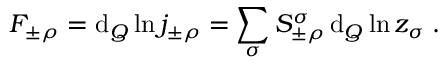<formula> <loc_0><loc_0><loc_500><loc_500>F _ { \pm \rho } = d _ { Q } \ln j _ { \pm \rho } ^ { \, } = \sum _ { \sigma } S _ { \pm \rho } ^ { \sigma } \, d _ { Q } \ln z _ { \sigma } ^ { \, } .</formula> 